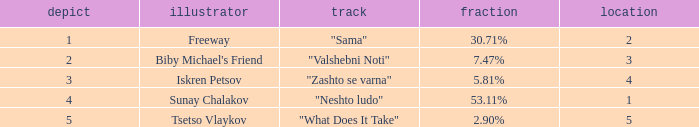What is the least draw when the place is higher than 4? 5.0. 